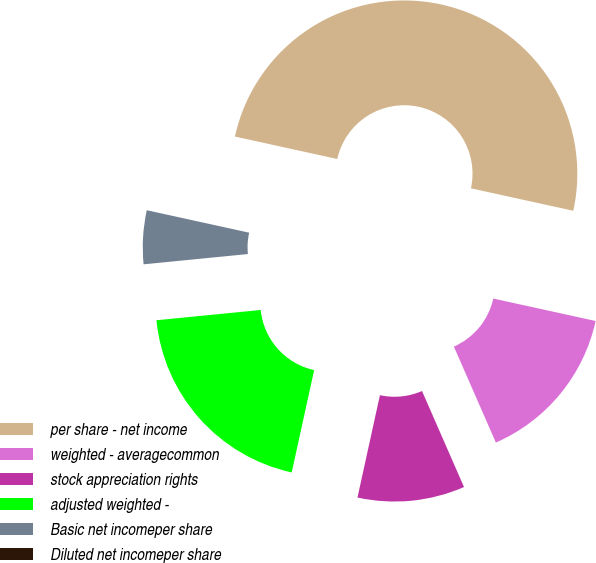Convert chart to OTSL. <chart><loc_0><loc_0><loc_500><loc_500><pie_chart><fcel>per share - net income<fcel>weighted - averagecommon<fcel>stock appreciation rights<fcel>adjusted weighted -<fcel>Basic net incomeper share<fcel>Diluted net incomeper share<nl><fcel>50.0%<fcel>15.0%<fcel>10.0%<fcel>20.0%<fcel>5.0%<fcel>0.0%<nl></chart> 